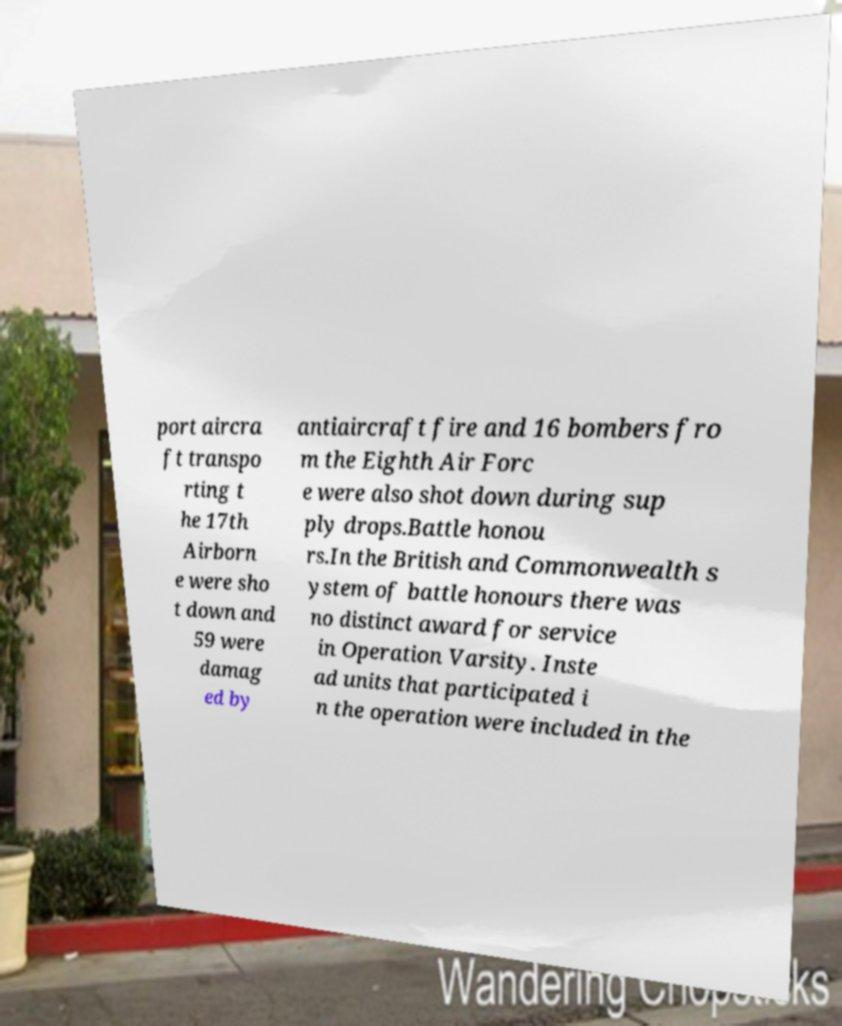I need the written content from this picture converted into text. Can you do that? port aircra ft transpo rting t he 17th Airborn e were sho t down and 59 were damag ed by antiaircraft fire and 16 bombers fro m the Eighth Air Forc e were also shot down during sup ply drops.Battle honou rs.In the British and Commonwealth s ystem of battle honours there was no distinct award for service in Operation Varsity. Inste ad units that participated i n the operation were included in the 